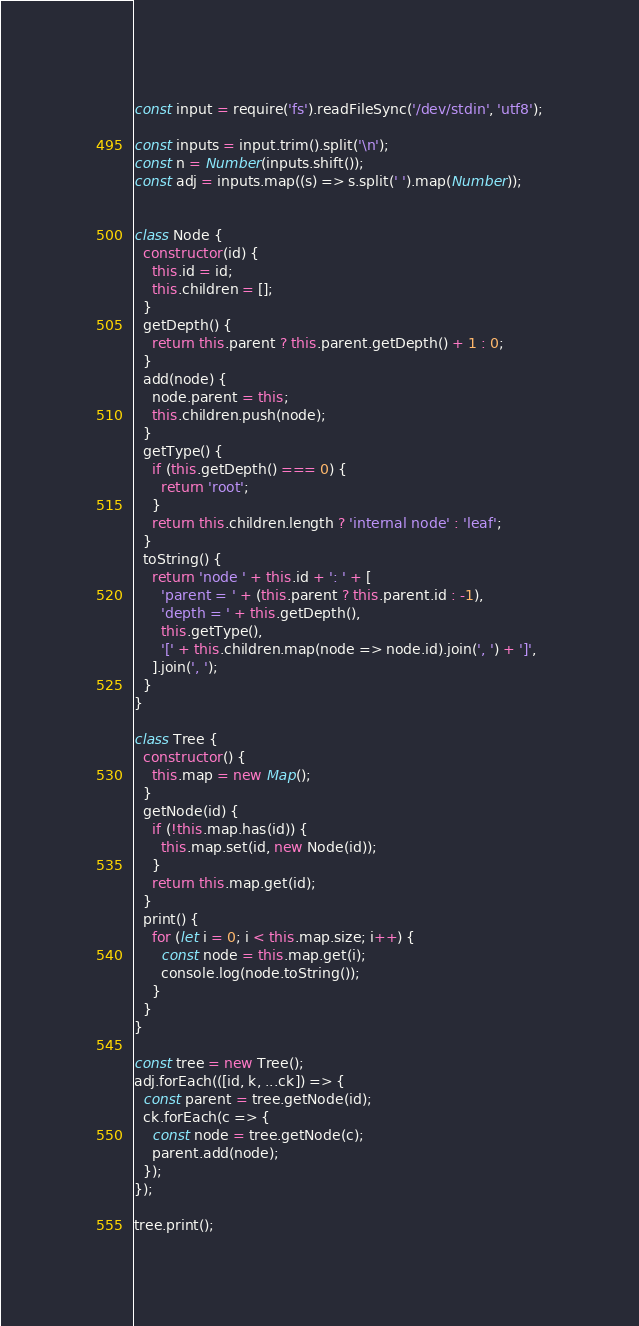<code> <loc_0><loc_0><loc_500><loc_500><_JavaScript_>const input = require('fs').readFileSync('/dev/stdin', 'utf8');

const inputs = input.trim().split('\n');
const n = Number(inputs.shift());
const adj = inputs.map((s) => s.split(' ').map(Number));


class Node {
  constructor(id) {
    this.id = id;
    this.children = [];
  }
  getDepth() {
    return this.parent ? this.parent.getDepth() + 1 : 0;
  }
  add(node) {
    node.parent = this;
    this.children.push(node);
  }
  getType() {
    if (this.getDepth() === 0) {
      return 'root';
    }
    return this.children.length ? 'internal node' : 'leaf';
  }
  toString() {
    return 'node ' + this.id + ': ' + [
      'parent = ' + (this.parent ? this.parent.id : -1),
      'depth = ' + this.getDepth(),
      this.getType(),
      '[' + this.children.map(node => node.id).join(', ') + ']',
    ].join(', ');
  }
}

class Tree {
  constructor() {
    this.map = new Map();
  }
  getNode(id) {
    if (!this.map.has(id)) {
      this.map.set(id, new Node(id));
    }
    return this.map.get(id);
  }
  print() {
    for (let i = 0; i < this.map.size; i++) {
      const node = this.map.get(i);
      console.log(node.toString());
    }
  }
}

const tree = new Tree();
adj.forEach(([id, k, ...ck]) => {
  const parent = tree.getNode(id);
  ck.forEach(c => {
    const node = tree.getNode(c);
    parent.add(node);
  });
});

tree.print();

</code> 